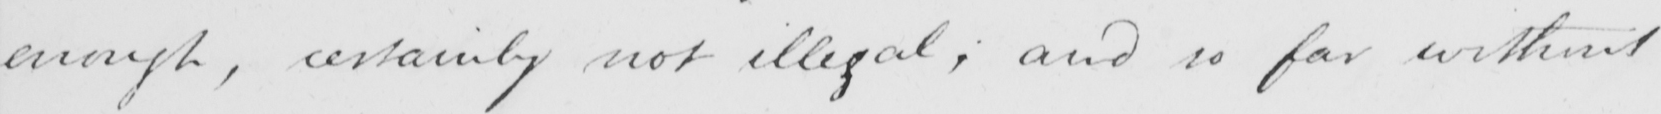Can you tell me what this handwritten text says? enough , certainly not illegal ; and so far without 